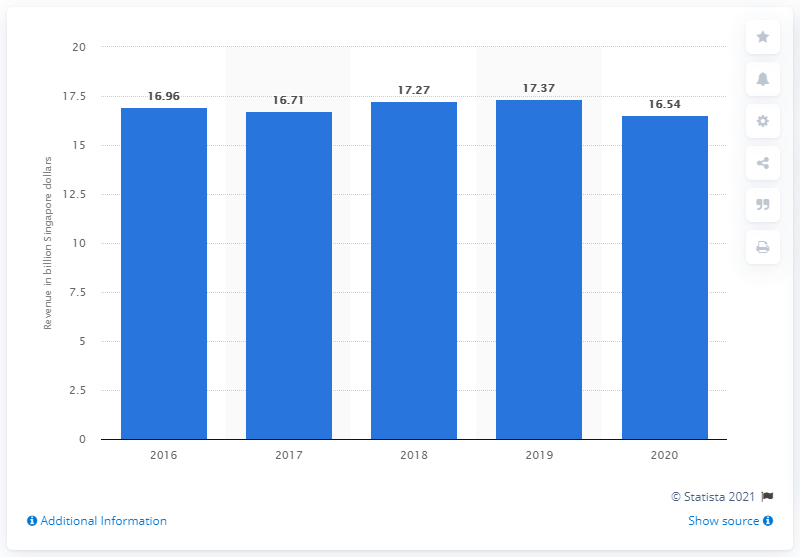Specify some key components in this picture. Singtel's operating revenue in financial year 2020 was 16.54. In financial year 2020, the operating revenue of Singapore Telecommunications (Singtel) Limited was SGD 16.54. 